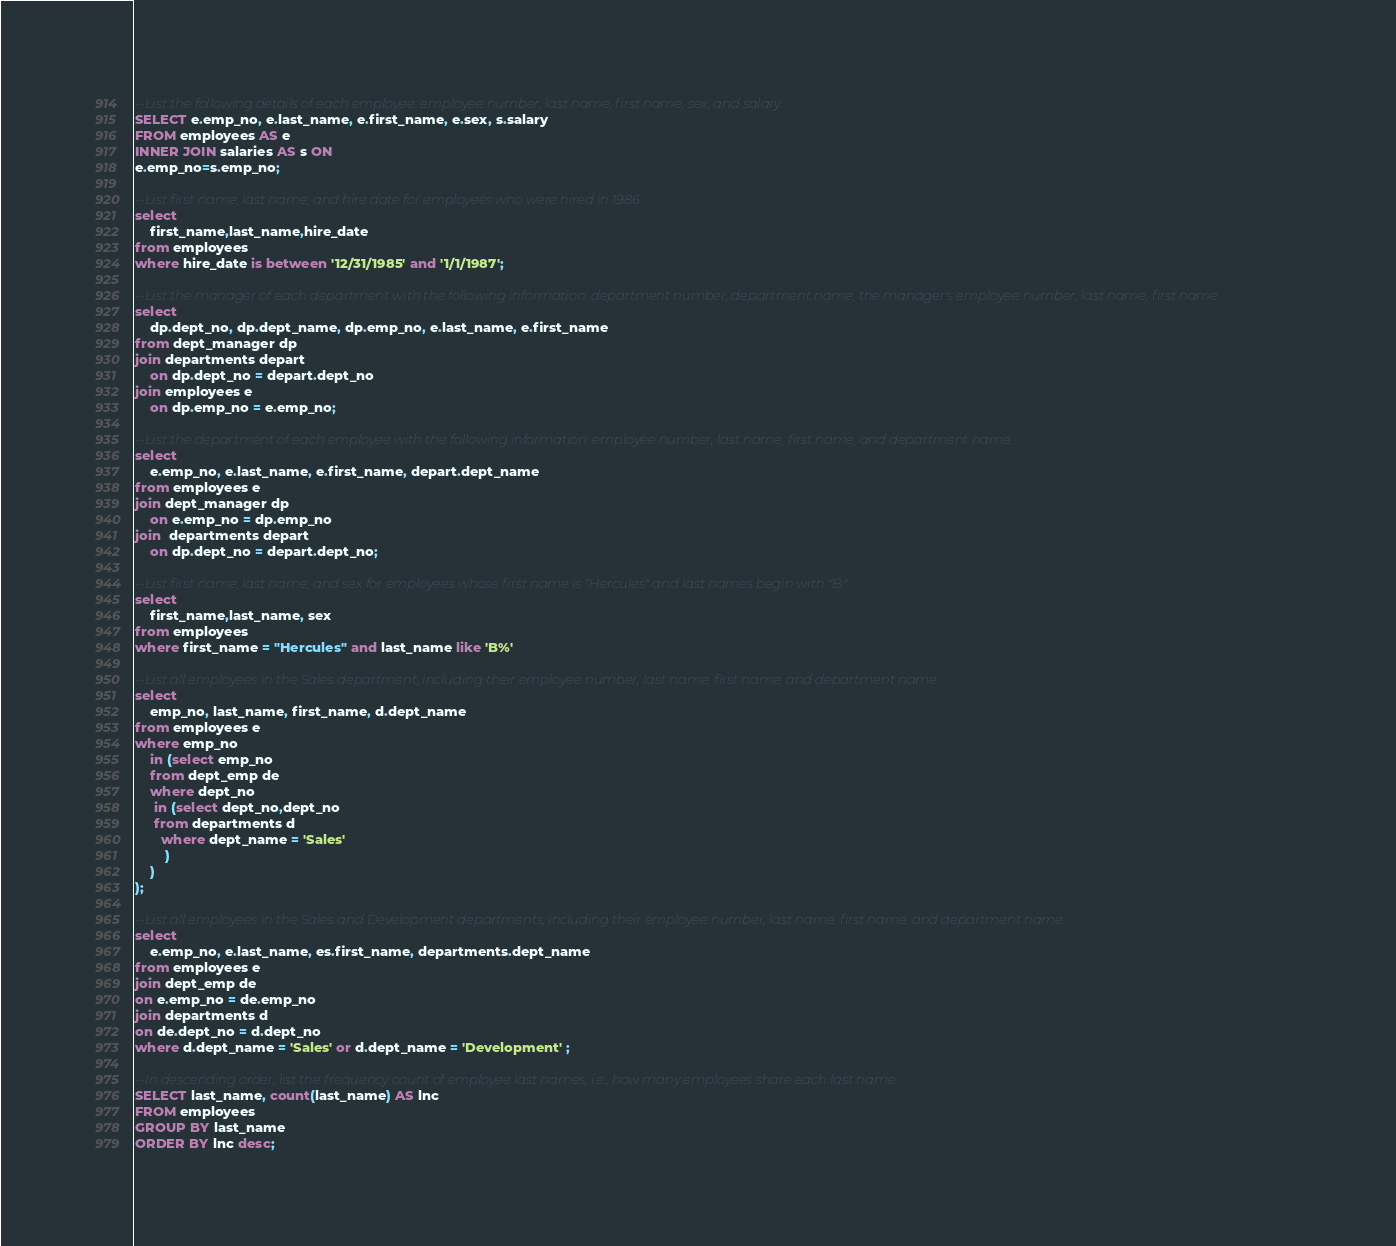<code> <loc_0><loc_0><loc_500><loc_500><_SQL_>--List the following details of each employee: employee number, last name, first name, sex, and salary.
SELECT e.emp_no, e.last_name, e.first_name, e.sex, s.salary
FROM employees AS e
INNER JOIN salaries AS s ON
e.emp_no=s.emp_no;

--List first name, last name, and hire date for employees who were hired in 1986.
select
    first_name,last_name,hire_date
from employees
where hire_date is between '12/31/1985' and '1/1/1987';

--List the manager of each department with the following information: department number, department name, the manager's employee number, last name, first name.
select 
    dp.dept_no, dp.dept_name, dp.emp_no, e.last_name, e.first_name
from dept_manager dp
join departments depart
    on dp.dept_no = depart.dept_no
join employees e
    on dp.emp_no = e.emp_no;

--List the department of each employee with the following information: employee number, last name, first name, and department name.
select
    e.emp_no, e.last_name, e.first_name, depart.dept_name
from employees e
join dept_manager dp
    on e.emp_no = dp.emp_no
join  departments depart 
    on dp.dept_no = depart.dept_no;
	
--List first name, last name, and sex for employees whose first name is "Hercules" and last names begin with "B."
select 
    first_name,last_name, sex
from employees
where first_name = "Hercules" and last_name like 'B%'

--List all employees in the Sales department, including their employee number, last name, first name, and department name.
select 
    emp_no, last_name, first_name, d.dept_name
from employees e
where emp_no 
    in (select emp_no
    from dept_emp de
    where dept_no  
     in (select dept_no,dept_no
     from departments d
       where dept_name = 'Sales'
        )
    )
);

--List all employees in the Sales and Development departments, including their employee number, last name, first name, and department name.
select 
    e.emp_no, e.last_name, es.first_name, departments.dept_name
from employees e
join dept_emp de
on e.emp_no = de.emp_no
join departments d
on de.dept_no = d.dept_no 
where d.dept_name = 'Sales' or d.dept_name = 'Development' ;

--In descending order, list the frequency count of employee last names, i.e., how many employees share each last name.
SELECT last_name, count(last_name) AS lnc
FROM employees
GROUP BY last_name
ORDER BY lnc desc;</code> 